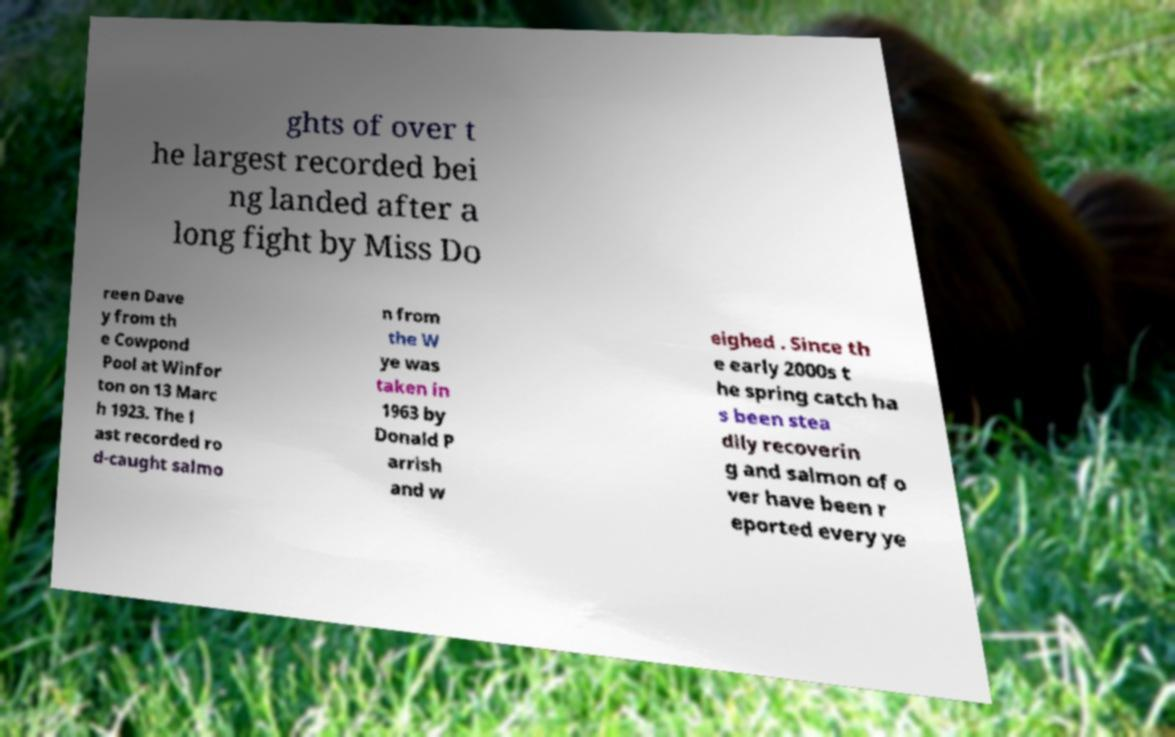What messages or text are displayed in this image? I need them in a readable, typed format. ghts of over t he largest recorded bei ng landed after a long fight by Miss Do reen Dave y from th e Cowpond Pool at Winfor ton on 13 Marc h 1923. The l ast recorded ro d-caught salmo n from the W ye was taken in 1963 by Donald P arrish and w eighed . Since th e early 2000s t he spring catch ha s been stea dily recoverin g and salmon of o ver have been r eported every ye 